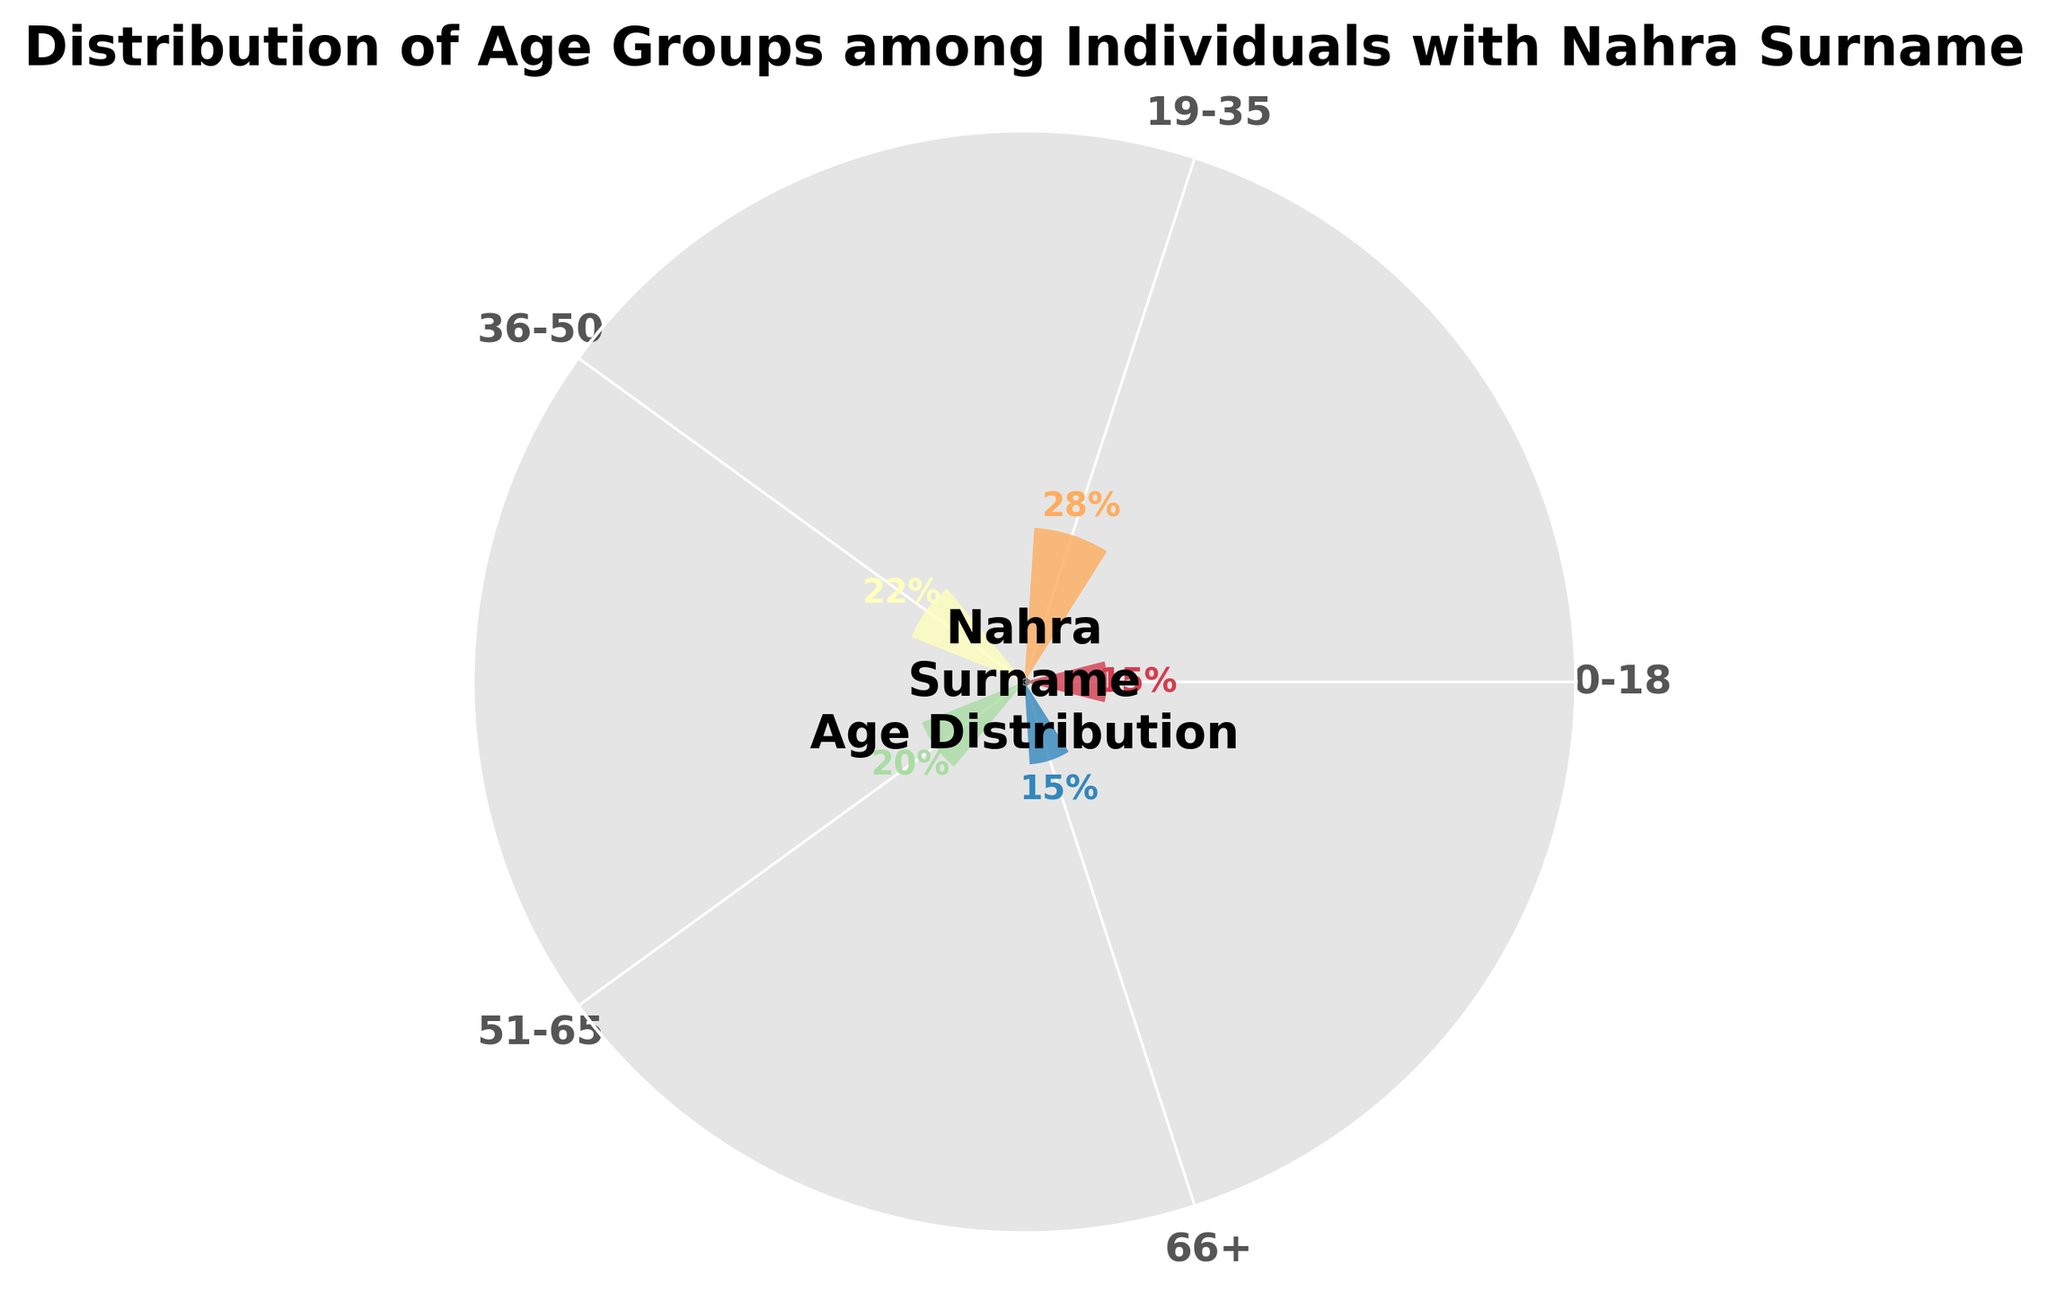What is the title of the chart? The title is the text displayed at the top of the chart, usually summarizing its content. In this case, it reads: "Distribution of Age Groups among Individuals with Nahra Surname".
Answer: Distribution of Age Groups among Individuals with Nahra Surname How many age groups are displayed in the chart? By counting the distinct categories displayed around the gauge, we can see there are a total of five age groups listed.
Answer: Five Which age group has the highest percentage? By observing the length of the segments and the labeled percentages, the age group 19-35 has the highest percentage at 28%.
Answer: 19-35 What is the combined percentage of age groups 0-18 and 66+? The percentages for age groups 0-18 and 66+ are both 15%. Adding these together gives a combined percentage of 15% + 15% = 30%.
Answer: 30% Compare the age groups 36-50 and 51-65. Which has a higher percentage, and by how much? The age group 36-50 has a percentage of 22%, whereas the age group 51-65 has 20%. The difference between these percentages is 22% - 20% = 2%.
Answer: 36-50 by 2% Which age groups have the same percentage? By observing the labeled percentages, we can see that the 0-18 and 66+ age groups both have the same percentage of 15%.
Answer: 0-18 and 66+ Estimate the angle covered by the segment for the age group 19-35. The segment representing the percentage of the age group 19-35, at 28%, translates to an angle. Since 100% is 180 degrees, 28% of 180 is approximately (180 * 28) / 100 = 50.4 degrees.
Answer: About 50.4 degrees What percentage of individuals are under 50 years old? Adding the individual percentages of the age groups 0-18 (15%), 19-35 (28%), and 36-50 (22%), the sum is 15% + 28% + 22% = 65%.
Answer: 65% What is the smallest segment, and what percentage does it represent? By comparing the labeled percentages visually, we observe that the smallest segment corresponds to the 0-18 and 66+ age groups, each representing 15%.
Answer: 15% 